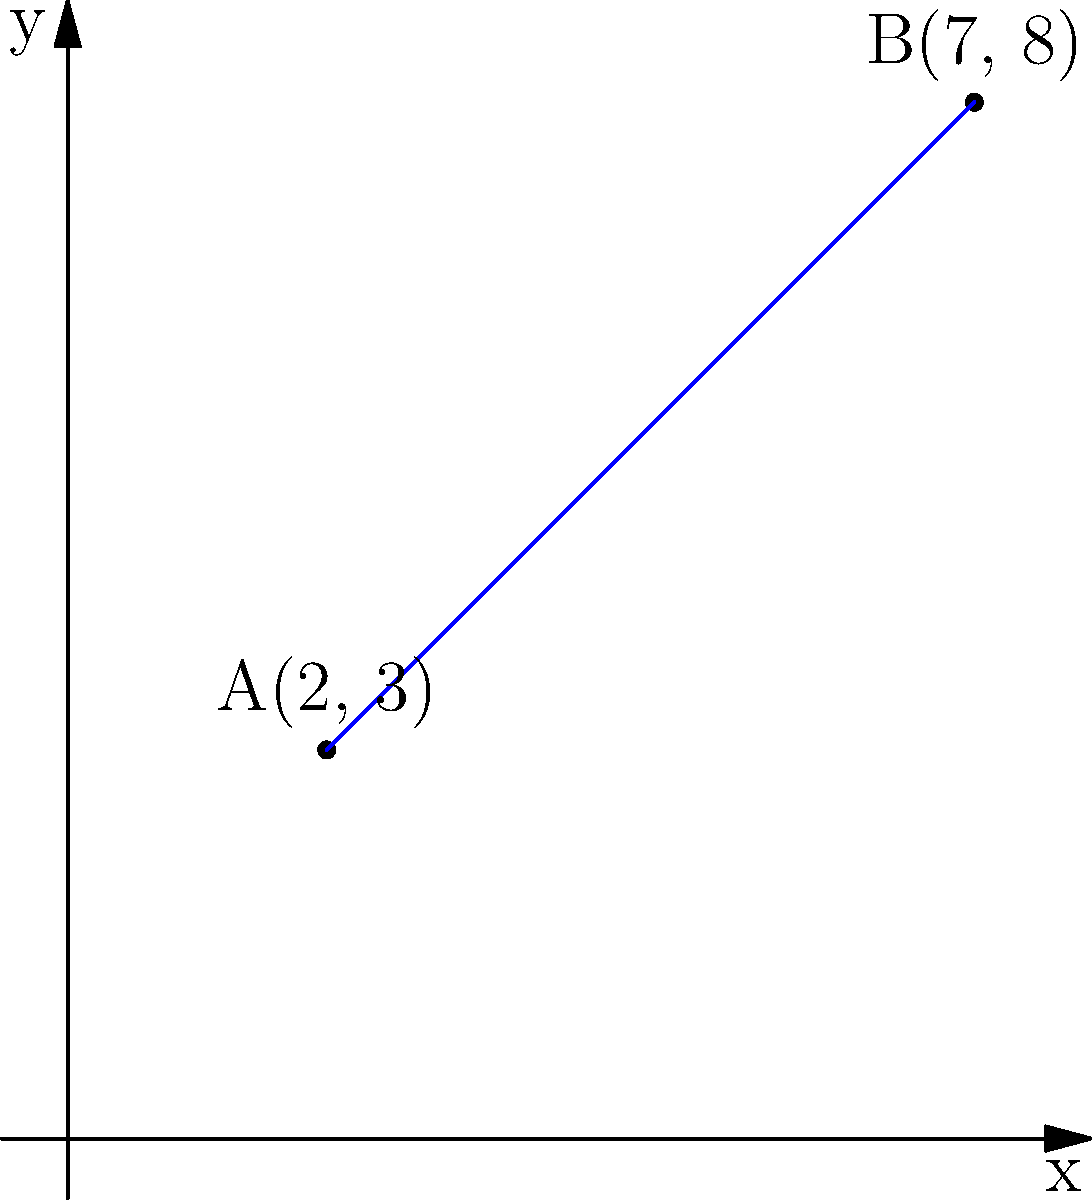Two students, living in different homes, want to meet at a central location. Student A lives at coordinates (2, 3), and Student B lives at coordinates (7, 8) on a city map. What is the straight-line distance between their homes? To find the distance between two points on a coordinate system, we can use the distance formula:

$$ d = \sqrt{(x_2 - x_1)^2 + (y_2 - y_1)^2} $$

Where $(x_1, y_1)$ is the coordinate of point A and $(x_2, y_2)$ is the coordinate of point B.

Step 1: Identify the coordinates
- Point A: $(x_1, y_1) = (2, 3)$
- Point B: $(x_2, y_2) = (7, 8)$

Step 2: Plug the values into the distance formula
$$ d = \sqrt{(7 - 2)^2 + (8 - 3)^2} $$

Step 3: Simplify the expressions inside the parentheses
$$ d = \sqrt{5^2 + 5^2} $$

Step 4: Calculate the squares
$$ d = \sqrt{25 + 25} $$

Step 5: Add the values under the square root
$$ d = \sqrt{50} $$

Step 6: Simplify the square root
$$ d = 5\sqrt{2} $$

Therefore, the straight-line distance between the two homes is $5\sqrt{2}$ units.
Answer: $5\sqrt{2}$ units 